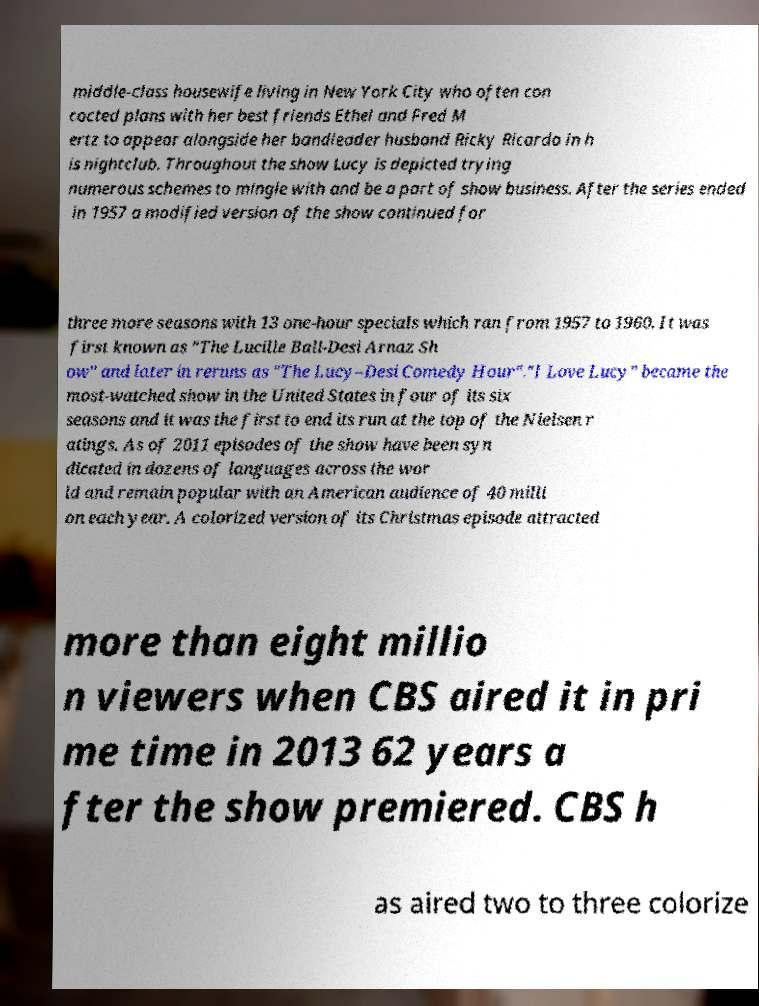Could you assist in decoding the text presented in this image and type it out clearly? middle-class housewife living in New York City who often con cocted plans with her best friends Ethel and Fred M ertz to appear alongside her bandleader husband Ricky Ricardo in h is nightclub. Throughout the show Lucy is depicted trying numerous schemes to mingle with and be a part of show business. After the series ended in 1957 a modified version of the show continued for three more seasons with 13 one-hour specials which ran from 1957 to 1960. It was first known as "The Lucille Ball-Desi Arnaz Sh ow" and later in reruns as "The Lucy–Desi Comedy Hour"."I Love Lucy" became the most-watched show in the United States in four of its six seasons and it was the first to end its run at the top of the Nielsen r atings. As of 2011 episodes of the show have been syn dicated in dozens of languages across the wor ld and remain popular with an American audience of 40 milli on each year. A colorized version of its Christmas episode attracted more than eight millio n viewers when CBS aired it in pri me time in 2013 62 years a fter the show premiered. CBS h as aired two to three colorize 